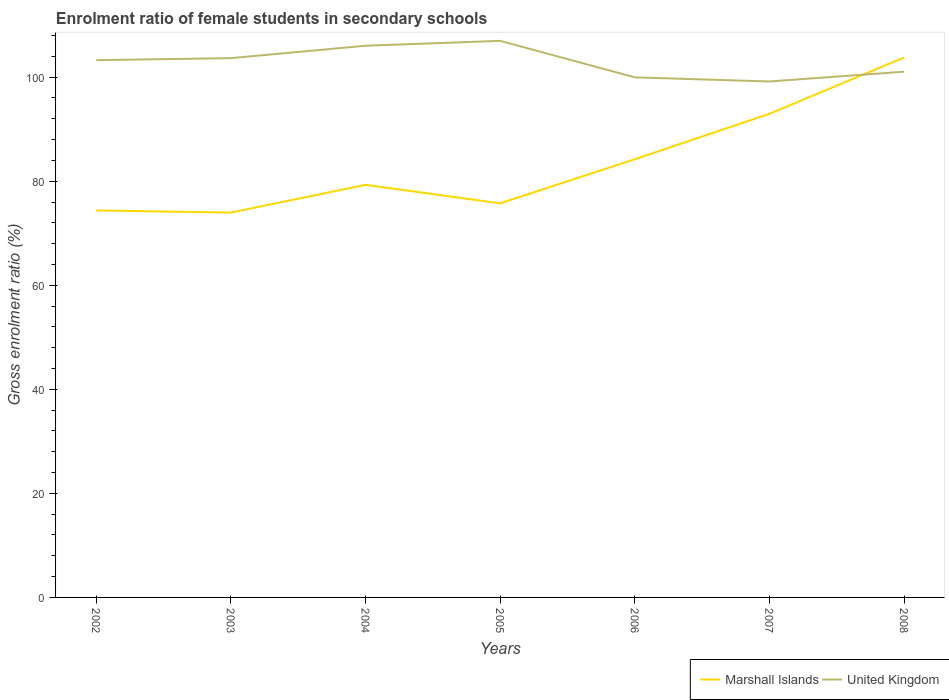How many different coloured lines are there?
Offer a very short reply. 2. Is the number of lines equal to the number of legend labels?
Ensure brevity in your answer.  Yes. Across all years, what is the maximum enrolment ratio of female students in secondary schools in United Kingdom?
Your answer should be very brief. 99.17. In which year was the enrolment ratio of female students in secondary schools in Marshall Islands maximum?
Keep it short and to the point. 2003. What is the total enrolment ratio of female students in secondary schools in Marshall Islands in the graph?
Your response must be concise. -17.21. What is the difference between the highest and the second highest enrolment ratio of female students in secondary schools in Marshall Islands?
Your answer should be very brief. 29.8. What is the difference between the highest and the lowest enrolment ratio of female students in secondary schools in Marshall Islands?
Your answer should be very brief. 3. Is the enrolment ratio of female students in secondary schools in United Kingdom strictly greater than the enrolment ratio of female students in secondary schools in Marshall Islands over the years?
Offer a terse response. No. How many years are there in the graph?
Offer a very short reply. 7. Does the graph contain any zero values?
Give a very brief answer. No. Does the graph contain grids?
Provide a succinct answer. No. Where does the legend appear in the graph?
Ensure brevity in your answer.  Bottom right. What is the title of the graph?
Your answer should be very brief. Enrolment ratio of female students in secondary schools. Does "San Marino" appear as one of the legend labels in the graph?
Give a very brief answer. No. What is the label or title of the X-axis?
Provide a short and direct response. Years. What is the label or title of the Y-axis?
Your answer should be compact. Gross enrolment ratio (%). What is the Gross enrolment ratio (%) in Marshall Islands in 2002?
Give a very brief answer. 74.38. What is the Gross enrolment ratio (%) in United Kingdom in 2002?
Your answer should be compact. 103.26. What is the Gross enrolment ratio (%) in Marshall Islands in 2003?
Provide a short and direct response. 73.97. What is the Gross enrolment ratio (%) of United Kingdom in 2003?
Keep it short and to the point. 103.65. What is the Gross enrolment ratio (%) in Marshall Islands in 2004?
Keep it short and to the point. 79.3. What is the Gross enrolment ratio (%) in United Kingdom in 2004?
Provide a short and direct response. 106.03. What is the Gross enrolment ratio (%) in Marshall Islands in 2005?
Your answer should be very brief. 75.74. What is the Gross enrolment ratio (%) of United Kingdom in 2005?
Provide a succinct answer. 106.98. What is the Gross enrolment ratio (%) in Marshall Islands in 2006?
Offer a very short reply. 84.22. What is the Gross enrolment ratio (%) in United Kingdom in 2006?
Provide a succinct answer. 99.96. What is the Gross enrolment ratio (%) in Marshall Islands in 2007?
Offer a very short reply. 92.95. What is the Gross enrolment ratio (%) of United Kingdom in 2007?
Offer a very short reply. 99.17. What is the Gross enrolment ratio (%) in Marshall Islands in 2008?
Your answer should be very brief. 103.77. What is the Gross enrolment ratio (%) in United Kingdom in 2008?
Ensure brevity in your answer.  101.04. Across all years, what is the maximum Gross enrolment ratio (%) in Marshall Islands?
Your answer should be very brief. 103.77. Across all years, what is the maximum Gross enrolment ratio (%) in United Kingdom?
Give a very brief answer. 106.98. Across all years, what is the minimum Gross enrolment ratio (%) of Marshall Islands?
Provide a short and direct response. 73.97. Across all years, what is the minimum Gross enrolment ratio (%) of United Kingdom?
Provide a succinct answer. 99.17. What is the total Gross enrolment ratio (%) of Marshall Islands in the graph?
Make the answer very short. 584.34. What is the total Gross enrolment ratio (%) in United Kingdom in the graph?
Keep it short and to the point. 720.08. What is the difference between the Gross enrolment ratio (%) of Marshall Islands in 2002 and that in 2003?
Make the answer very short. 0.41. What is the difference between the Gross enrolment ratio (%) of United Kingdom in 2002 and that in 2003?
Ensure brevity in your answer.  -0.39. What is the difference between the Gross enrolment ratio (%) of Marshall Islands in 2002 and that in 2004?
Ensure brevity in your answer.  -4.92. What is the difference between the Gross enrolment ratio (%) in United Kingdom in 2002 and that in 2004?
Your response must be concise. -2.77. What is the difference between the Gross enrolment ratio (%) of Marshall Islands in 2002 and that in 2005?
Your answer should be very brief. -1.36. What is the difference between the Gross enrolment ratio (%) of United Kingdom in 2002 and that in 2005?
Offer a very short reply. -3.71. What is the difference between the Gross enrolment ratio (%) in Marshall Islands in 2002 and that in 2006?
Provide a succinct answer. -9.84. What is the difference between the Gross enrolment ratio (%) of United Kingdom in 2002 and that in 2006?
Give a very brief answer. 3.31. What is the difference between the Gross enrolment ratio (%) in Marshall Islands in 2002 and that in 2007?
Your answer should be compact. -18.57. What is the difference between the Gross enrolment ratio (%) in United Kingdom in 2002 and that in 2007?
Provide a succinct answer. 4.1. What is the difference between the Gross enrolment ratio (%) in Marshall Islands in 2002 and that in 2008?
Give a very brief answer. -29.39. What is the difference between the Gross enrolment ratio (%) in United Kingdom in 2002 and that in 2008?
Offer a terse response. 2.22. What is the difference between the Gross enrolment ratio (%) in Marshall Islands in 2003 and that in 2004?
Make the answer very short. -5.33. What is the difference between the Gross enrolment ratio (%) in United Kingdom in 2003 and that in 2004?
Provide a succinct answer. -2.38. What is the difference between the Gross enrolment ratio (%) in Marshall Islands in 2003 and that in 2005?
Your answer should be very brief. -1.78. What is the difference between the Gross enrolment ratio (%) of United Kingdom in 2003 and that in 2005?
Your answer should be compact. -3.33. What is the difference between the Gross enrolment ratio (%) of Marshall Islands in 2003 and that in 2006?
Your response must be concise. -10.25. What is the difference between the Gross enrolment ratio (%) of United Kingdom in 2003 and that in 2006?
Provide a short and direct response. 3.69. What is the difference between the Gross enrolment ratio (%) in Marshall Islands in 2003 and that in 2007?
Give a very brief answer. -18.98. What is the difference between the Gross enrolment ratio (%) in United Kingdom in 2003 and that in 2007?
Offer a terse response. 4.48. What is the difference between the Gross enrolment ratio (%) in Marshall Islands in 2003 and that in 2008?
Your answer should be very brief. -29.8. What is the difference between the Gross enrolment ratio (%) in United Kingdom in 2003 and that in 2008?
Provide a succinct answer. 2.61. What is the difference between the Gross enrolment ratio (%) in Marshall Islands in 2004 and that in 2005?
Provide a succinct answer. 3.55. What is the difference between the Gross enrolment ratio (%) in United Kingdom in 2004 and that in 2005?
Offer a terse response. -0.94. What is the difference between the Gross enrolment ratio (%) in Marshall Islands in 2004 and that in 2006?
Your answer should be very brief. -4.93. What is the difference between the Gross enrolment ratio (%) in United Kingdom in 2004 and that in 2006?
Ensure brevity in your answer.  6.08. What is the difference between the Gross enrolment ratio (%) of Marshall Islands in 2004 and that in 2007?
Your answer should be compact. -13.66. What is the difference between the Gross enrolment ratio (%) in United Kingdom in 2004 and that in 2007?
Ensure brevity in your answer.  6.87. What is the difference between the Gross enrolment ratio (%) of Marshall Islands in 2004 and that in 2008?
Your answer should be compact. -24.47. What is the difference between the Gross enrolment ratio (%) in United Kingdom in 2004 and that in 2008?
Your answer should be compact. 4.99. What is the difference between the Gross enrolment ratio (%) of Marshall Islands in 2005 and that in 2006?
Your answer should be very brief. -8.48. What is the difference between the Gross enrolment ratio (%) in United Kingdom in 2005 and that in 2006?
Offer a very short reply. 7.02. What is the difference between the Gross enrolment ratio (%) of Marshall Islands in 2005 and that in 2007?
Give a very brief answer. -17.21. What is the difference between the Gross enrolment ratio (%) in United Kingdom in 2005 and that in 2007?
Offer a very short reply. 7.81. What is the difference between the Gross enrolment ratio (%) of Marshall Islands in 2005 and that in 2008?
Offer a very short reply. -28.03. What is the difference between the Gross enrolment ratio (%) in United Kingdom in 2005 and that in 2008?
Offer a terse response. 5.93. What is the difference between the Gross enrolment ratio (%) of Marshall Islands in 2006 and that in 2007?
Your answer should be compact. -8.73. What is the difference between the Gross enrolment ratio (%) of United Kingdom in 2006 and that in 2007?
Ensure brevity in your answer.  0.79. What is the difference between the Gross enrolment ratio (%) of Marshall Islands in 2006 and that in 2008?
Offer a terse response. -19.55. What is the difference between the Gross enrolment ratio (%) of United Kingdom in 2006 and that in 2008?
Your response must be concise. -1.09. What is the difference between the Gross enrolment ratio (%) of Marshall Islands in 2007 and that in 2008?
Provide a succinct answer. -10.82. What is the difference between the Gross enrolment ratio (%) of United Kingdom in 2007 and that in 2008?
Give a very brief answer. -1.88. What is the difference between the Gross enrolment ratio (%) in Marshall Islands in 2002 and the Gross enrolment ratio (%) in United Kingdom in 2003?
Your answer should be compact. -29.27. What is the difference between the Gross enrolment ratio (%) in Marshall Islands in 2002 and the Gross enrolment ratio (%) in United Kingdom in 2004?
Make the answer very short. -31.65. What is the difference between the Gross enrolment ratio (%) of Marshall Islands in 2002 and the Gross enrolment ratio (%) of United Kingdom in 2005?
Your response must be concise. -32.6. What is the difference between the Gross enrolment ratio (%) of Marshall Islands in 2002 and the Gross enrolment ratio (%) of United Kingdom in 2006?
Offer a terse response. -25.58. What is the difference between the Gross enrolment ratio (%) of Marshall Islands in 2002 and the Gross enrolment ratio (%) of United Kingdom in 2007?
Ensure brevity in your answer.  -24.79. What is the difference between the Gross enrolment ratio (%) of Marshall Islands in 2002 and the Gross enrolment ratio (%) of United Kingdom in 2008?
Your response must be concise. -26.66. What is the difference between the Gross enrolment ratio (%) in Marshall Islands in 2003 and the Gross enrolment ratio (%) in United Kingdom in 2004?
Your answer should be very brief. -32.06. What is the difference between the Gross enrolment ratio (%) of Marshall Islands in 2003 and the Gross enrolment ratio (%) of United Kingdom in 2005?
Ensure brevity in your answer.  -33.01. What is the difference between the Gross enrolment ratio (%) in Marshall Islands in 2003 and the Gross enrolment ratio (%) in United Kingdom in 2006?
Keep it short and to the point. -25.99. What is the difference between the Gross enrolment ratio (%) of Marshall Islands in 2003 and the Gross enrolment ratio (%) of United Kingdom in 2007?
Your answer should be compact. -25.2. What is the difference between the Gross enrolment ratio (%) in Marshall Islands in 2003 and the Gross enrolment ratio (%) in United Kingdom in 2008?
Offer a very short reply. -27.07. What is the difference between the Gross enrolment ratio (%) of Marshall Islands in 2004 and the Gross enrolment ratio (%) of United Kingdom in 2005?
Offer a very short reply. -27.68. What is the difference between the Gross enrolment ratio (%) in Marshall Islands in 2004 and the Gross enrolment ratio (%) in United Kingdom in 2006?
Make the answer very short. -20.66. What is the difference between the Gross enrolment ratio (%) of Marshall Islands in 2004 and the Gross enrolment ratio (%) of United Kingdom in 2007?
Provide a succinct answer. -19.87. What is the difference between the Gross enrolment ratio (%) of Marshall Islands in 2004 and the Gross enrolment ratio (%) of United Kingdom in 2008?
Provide a short and direct response. -21.74. What is the difference between the Gross enrolment ratio (%) of Marshall Islands in 2005 and the Gross enrolment ratio (%) of United Kingdom in 2006?
Provide a short and direct response. -24.21. What is the difference between the Gross enrolment ratio (%) in Marshall Islands in 2005 and the Gross enrolment ratio (%) in United Kingdom in 2007?
Offer a terse response. -23.42. What is the difference between the Gross enrolment ratio (%) in Marshall Islands in 2005 and the Gross enrolment ratio (%) in United Kingdom in 2008?
Give a very brief answer. -25.3. What is the difference between the Gross enrolment ratio (%) in Marshall Islands in 2006 and the Gross enrolment ratio (%) in United Kingdom in 2007?
Your response must be concise. -14.94. What is the difference between the Gross enrolment ratio (%) of Marshall Islands in 2006 and the Gross enrolment ratio (%) of United Kingdom in 2008?
Provide a short and direct response. -16.82. What is the difference between the Gross enrolment ratio (%) of Marshall Islands in 2007 and the Gross enrolment ratio (%) of United Kingdom in 2008?
Keep it short and to the point. -8.09. What is the average Gross enrolment ratio (%) in Marshall Islands per year?
Your answer should be very brief. 83.48. What is the average Gross enrolment ratio (%) of United Kingdom per year?
Provide a succinct answer. 102.87. In the year 2002, what is the difference between the Gross enrolment ratio (%) in Marshall Islands and Gross enrolment ratio (%) in United Kingdom?
Offer a terse response. -28.88. In the year 2003, what is the difference between the Gross enrolment ratio (%) of Marshall Islands and Gross enrolment ratio (%) of United Kingdom?
Give a very brief answer. -29.68. In the year 2004, what is the difference between the Gross enrolment ratio (%) of Marshall Islands and Gross enrolment ratio (%) of United Kingdom?
Your answer should be very brief. -26.73. In the year 2005, what is the difference between the Gross enrolment ratio (%) in Marshall Islands and Gross enrolment ratio (%) in United Kingdom?
Your response must be concise. -31.23. In the year 2006, what is the difference between the Gross enrolment ratio (%) of Marshall Islands and Gross enrolment ratio (%) of United Kingdom?
Your response must be concise. -15.73. In the year 2007, what is the difference between the Gross enrolment ratio (%) of Marshall Islands and Gross enrolment ratio (%) of United Kingdom?
Your response must be concise. -6.21. In the year 2008, what is the difference between the Gross enrolment ratio (%) of Marshall Islands and Gross enrolment ratio (%) of United Kingdom?
Ensure brevity in your answer.  2.73. What is the ratio of the Gross enrolment ratio (%) in Marshall Islands in 2002 to that in 2003?
Provide a succinct answer. 1.01. What is the ratio of the Gross enrolment ratio (%) of Marshall Islands in 2002 to that in 2004?
Ensure brevity in your answer.  0.94. What is the ratio of the Gross enrolment ratio (%) in United Kingdom in 2002 to that in 2004?
Your answer should be compact. 0.97. What is the ratio of the Gross enrolment ratio (%) of Marshall Islands in 2002 to that in 2005?
Offer a terse response. 0.98. What is the ratio of the Gross enrolment ratio (%) in United Kingdom in 2002 to that in 2005?
Give a very brief answer. 0.97. What is the ratio of the Gross enrolment ratio (%) of Marshall Islands in 2002 to that in 2006?
Provide a short and direct response. 0.88. What is the ratio of the Gross enrolment ratio (%) of United Kingdom in 2002 to that in 2006?
Offer a terse response. 1.03. What is the ratio of the Gross enrolment ratio (%) in Marshall Islands in 2002 to that in 2007?
Provide a short and direct response. 0.8. What is the ratio of the Gross enrolment ratio (%) of United Kingdom in 2002 to that in 2007?
Provide a short and direct response. 1.04. What is the ratio of the Gross enrolment ratio (%) of Marshall Islands in 2002 to that in 2008?
Provide a short and direct response. 0.72. What is the ratio of the Gross enrolment ratio (%) of Marshall Islands in 2003 to that in 2004?
Make the answer very short. 0.93. What is the ratio of the Gross enrolment ratio (%) of United Kingdom in 2003 to that in 2004?
Your response must be concise. 0.98. What is the ratio of the Gross enrolment ratio (%) in Marshall Islands in 2003 to that in 2005?
Give a very brief answer. 0.98. What is the ratio of the Gross enrolment ratio (%) of United Kingdom in 2003 to that in 2005?
Your answer should be compact. 0.97. What is the ratio of the Gross enrolment ratio (%) in Marshall Islands in 2003 to that in 2006?
Your response must be concise. 0.88. What is the ratio of the Gross enrolment ratio (%) of United Kingdom in 2003 to that in 2006?
Your response must be concise. 1.04. What is the ratio of the Gross enrolment ratio (%) in Marshall Islands in 2003 to that in 2007?
Provide a succinct answer. 0.8. What is the ratio of the Gross enrolment ratio (%) in United Kingdom in 2003 to that in 2007?
Offer a very short reply. 1.05. What is the ratio of the Gross enrolment ratio (%) of Marshall Islands in 2003 to that in 2008?
Offer a very short reply. 0.71. What is the ratio of the Gross enrolment ratio (%) of United Kingdom in 2003 to that in 2008?
Offer a very short reply. 1.03. What is the ratio of the Gross enrolment ratio (%) in Marshall Islands in 2004 to that in 2005?
Your answer should be compact. 1.05. What is the ratio of the Gross enrolment ratio (%) in United Kingdom in 2004 to that in 2005?
Give a very brief answer. 0.99. What is the ratio of the Gross enrolment ratio (%) of Marshall Islands in 2004 to that in 2006?
Make the answer very short. 0.94. What is the ratio of the Gross enrolment ratio (%) of United Kingdom in 2004 to that in 2006?
Your answer should be very brief. 1.06. What is the ratio of the Gross enrolment ratio (%) of Marshall Islands in 2004 to that in 2007?
Offer a very short reply. 0.85. What is the ratio of the Gross enrolment ratio (%) in United Kingdom in 2004 to that in 2007?
Keep it short and to the point. 1.07. What is the ratio of the Gross enrolment ratio (%) of Marshall Islands in 2004 to that in 2008?
Provide a succinct answer. 0.76. What is the ratio of the Gross enrolment ratio (%) in United Kingdom in 2004 to that in 2008?
Ensure brevity in your answer.  1.05. What is the ratio of the Gross enrolment ratio (%) in Marshall Islands in 2005 to that in 2006?
Make the answer very short. 0.9. What is the ratio of the Gross enrolment ratio (%) in United Kingdom in 2005 to that in 2006?
Offer a terse response. 1.07. What is the ratio of the Gross enrolment ratio (%) in Marshall Islands in 2005 to that in 2007?
Make the answer very short. 0.81. What is the ratio of the Gross enrolment ratio (%) of United Kingdom in 2005 to that in 2007?
Provide a succinct answer. 1.08. What is the ratio of the Gross enrolment ratio (%) in Marshall Islands in 2005 to that in 2008?
Your answer should be very brief. 0.73. What is the ratio of the Gross enrolment ratio (%) of United Kingdom in 2005 to that in 2008?
Give a very brief answer. 1.06. What is the ratio of the Gross enrolment ratio (%) in Marshall Islands in 2006 to that in 2007?
Your answer should be very brief. 0.91. What is the ratio of the Gross enrolment ratio (%) of United Kingdom in 2006 to that in 2007?
Your answer should be compact. 1.01. What is the ratio of the Gross enrolment ratio (%) in Marshall Islands in 2006 to that in 2008?
Make the answer very short. 0.81. What is the ratio of the Gross enrolment ratio (%) of Marshall Islands in 2007 to that in 2008?
Offer a terse response. 0.9. What is the ratio of the Gross enrolment ratio (%) of United Kingdom in 2007 to that in 2008?
Your answer should be compact. 0.98. What is the difference between the highest and the second highest Gross enrolment ratio (%) of Marshall Islands?
Give a very brief answer. 10.82. What is the difference between the highest and the second highest Gross enrolment ratio (%) in United Kingdom?
Make the answer very short. 0.94. What is the difference between the highest and the lowest Gross enrolment ratio (%) in Marshall Islands?
Provide a succinct answer. 29.8. What is the difference between the highest and the lowest Gross enrolment ratio (%) in United Kingdom?
Keep it short and to the point. 7.81. 